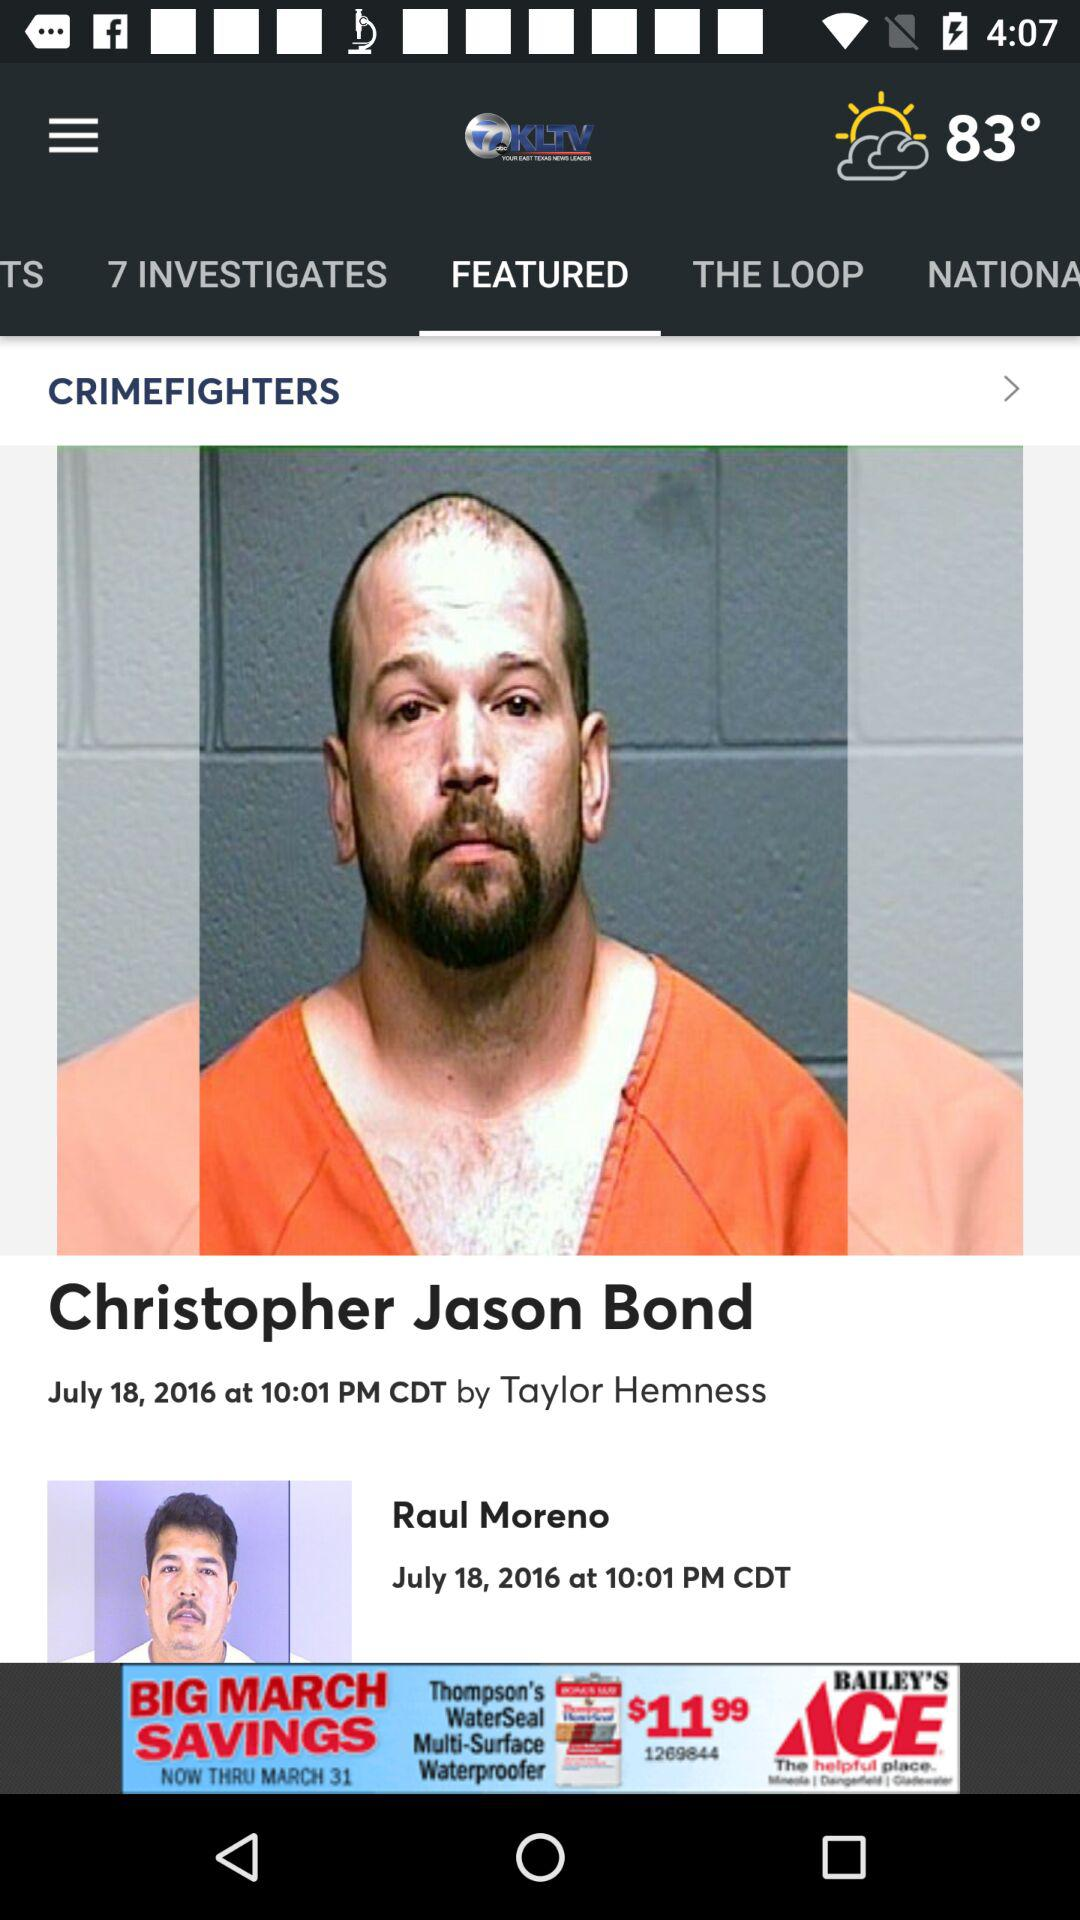What is the name of the reporter? The name of the reporter is Taylor Hemness. 